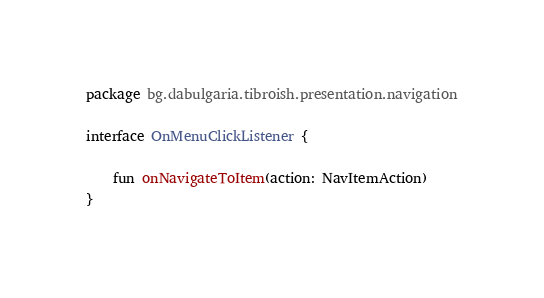Convert code to text. <code><loc_0><loc_0><loc_500><loc_500><_Kotlin_>package bg.dabulgaria.tibroish.presentation.navigation

interface OnMenuClickListener {

    fun onNavigateToItem(action: NavItemAction)
}</code> 